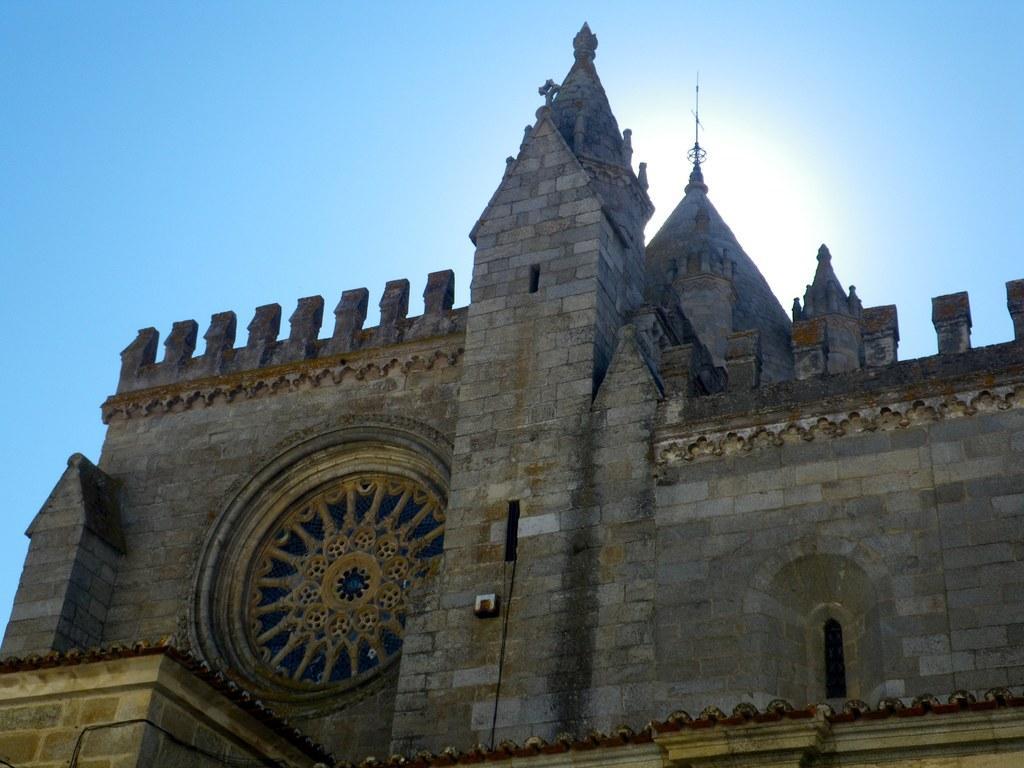Could you give a brief overview of what you see in this image? In the image we can see there is a building and the building is made up of stone bricks. There is a clear sky. 